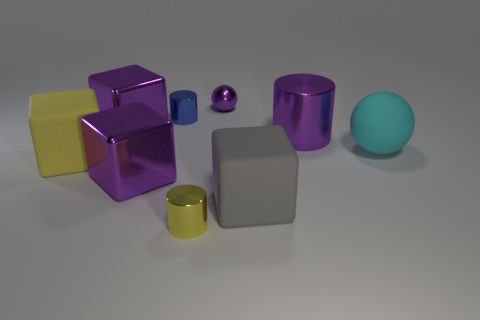Subtract all purple cylinders. How many cylinders are left? 2 Subtract all blue cylinders. How many purple cubes are left? 2 Subtract all blue cylinders. How many cylinders are left? 2 Subtract 2 spheres. How many spheres are left? 0 Subtract all balls. How many objects are left? 7 Subtract all gray cylinders. Subtract all brown blocks. How many cylinders are left? 3 Subtract all small green metal balls. Subtract all big yellow objects. How many objects are left? 8 Add 7 purple metal spheres. How many purple metal spheres are left? 8 Add 2 large cubes. How many large cubes exist? 6 Subtract 1 yellow cubes. How many objects are left? 8 